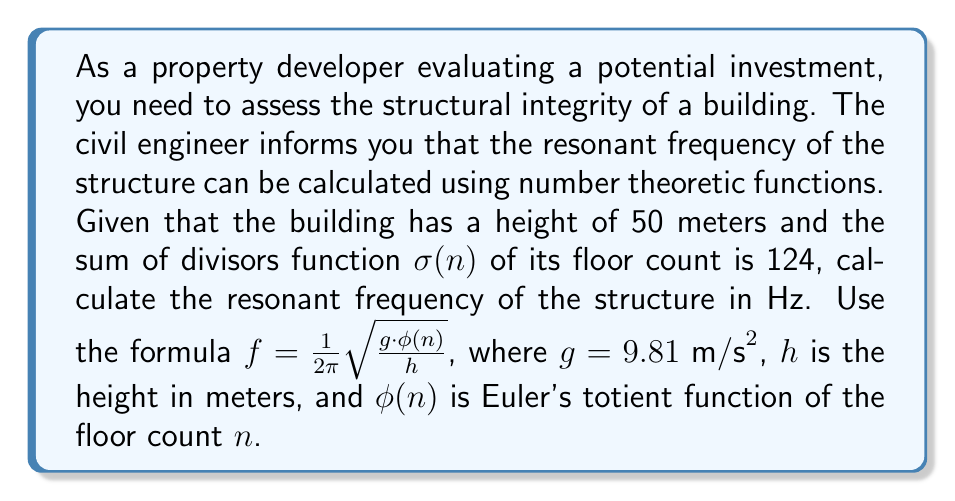Provide a solution to this math problem. To solve this problem, we need to follow these steps:

1. Determine the number of floors ($n$) using the sum of divisors function $\sigma(n)$.
2. Calculate Euler's totient function $\phi(n)$ for the floor count.
3. Apply the given formula to find the resonant frequency.

Step 1: Find $n$ using $\sigma(n) = 124$
The sum of divisors function $\sigma(n)$ is given as 124. We need to find $n$ such that the sum of its divisors equals 124. By trial and error or using a computer program, we find that:

$\sigma(60) = 1 + 2 + 3 + 4 + 5 + 6 + 10 + 12 + 15 + 20 + 30 + 60 = 168$
$\sigma(58) = 1 + 2 + 29 + 58 = 90$
$\sigma(59) = 1 + 59 = 60$
$\sigma(61) = 1 + 61 = 62$

Therefore, $n = 62$ floors, as $\sigma(62) = 1 + 2 + 31 + 62 = 124$

Step 2: Calculate $\phi(62)$
Euler's totient function $\phi(n)$ counts the number of integers up to $n$ that are coprime to $n$. For a prime $p$, $\phi(p) = p - 1$. For $62 = 2 \times 31$, we can use the multiplicative property of $\phi$:

$\phi(62) = \phi(2) \times \phi(31) = 1 \times 30 = 30$

Step 3: Apply the formula
Now we can use the given formula:

$f = \frac{1}{2\pi} \sqrt{\frac{g \cdot \phi(n)}{h}}$

Substituting the values:
$g = 9.81 \text{ m/s}^2$
$\phi(n) = 30$
$h = 50 \text{ m}$

$$f = \frac{1}{2\pi} \sqrt{\frac{9.81 \cdot 30}{50}} = \frac{1}{2\pi} \sqrt{5.886} \approx 0.3861 \text{ Hz}$$
Answer: $0.3861 \text{ Hz}$ 